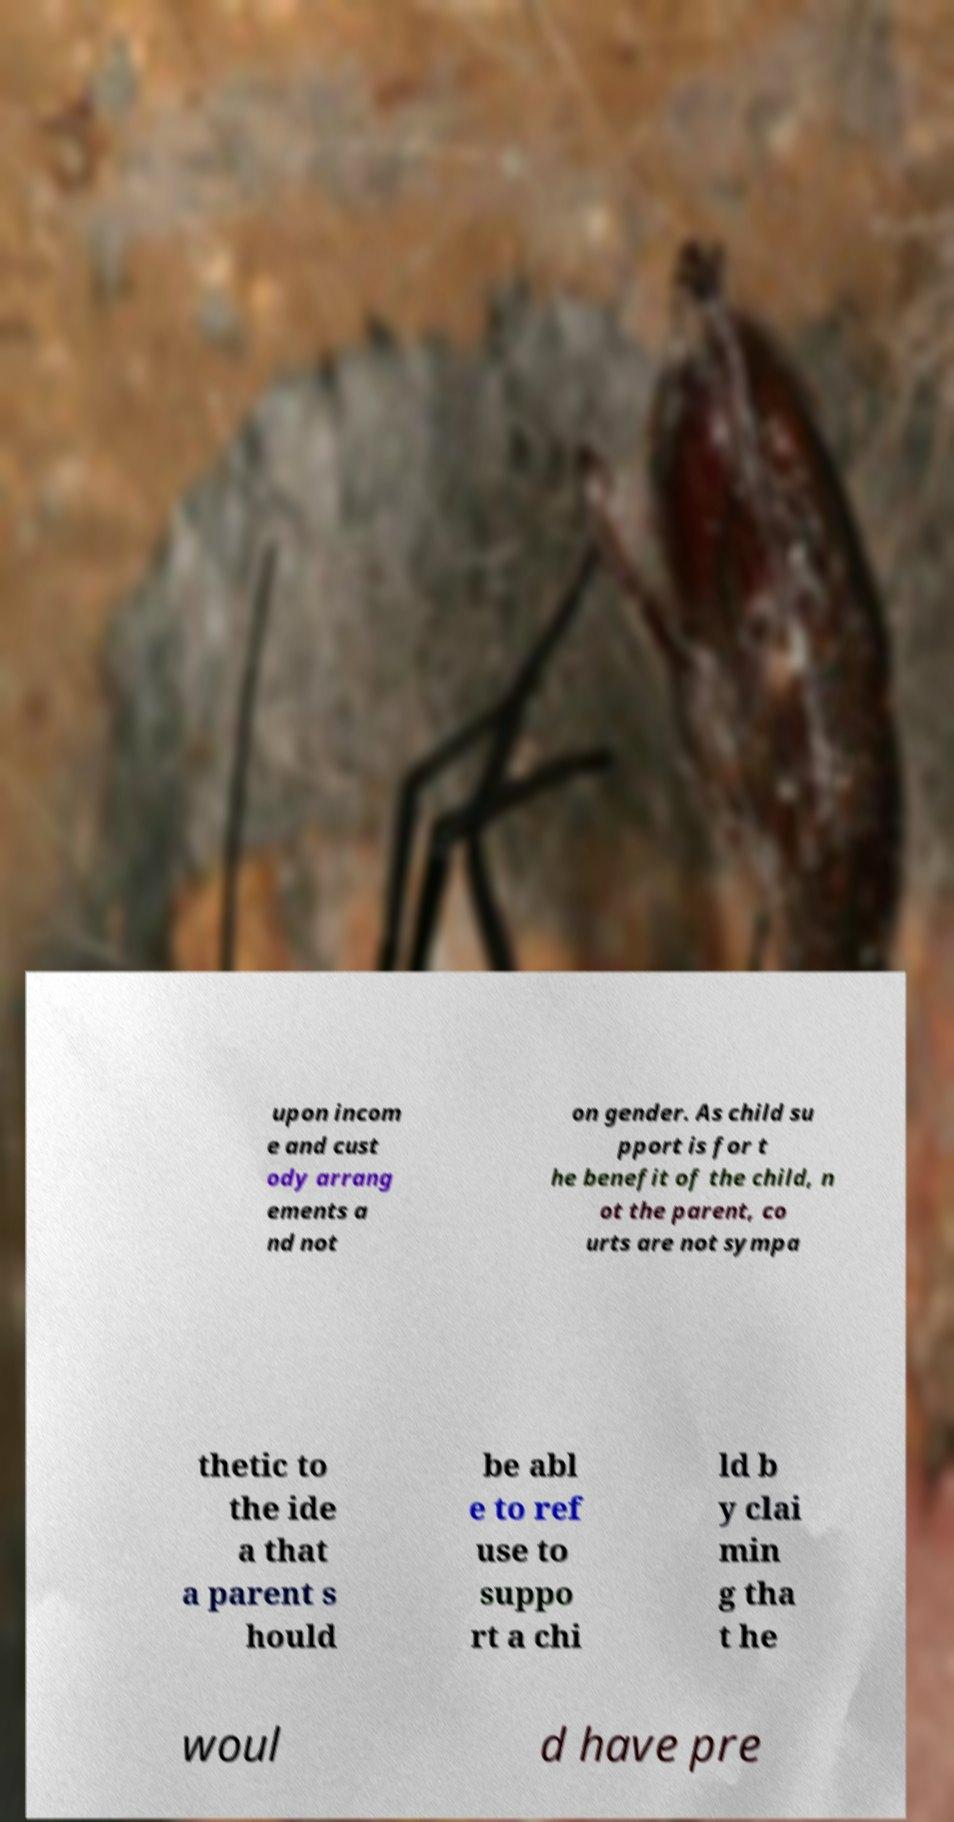I need the written content from this picture converted into text. Can you do that? upon incom e and cust ody arrang ements a nd not on gender. As child su pport is for t he benefit of the child, n ot the parent, co urts are not sympa thetic to the ide a that a parent s hould be abl e to ref use to suppo rt a chi ld b y clai min g tha t he woul d have pre 